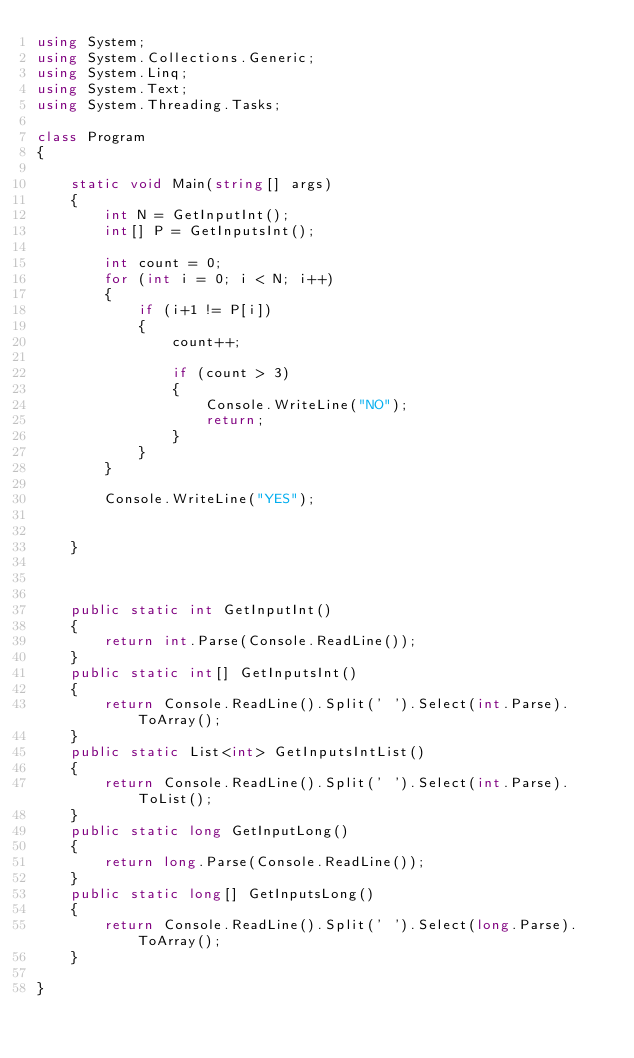Convert code to text. <code><loc_0><loc_0><loc_500><loc_500><_C#_>using System;
using System.Collections.Generic;
using System.Linq;
using System.Text;
using System.Threading.Tasks;
 
class Program
{
 
    static void Main(string[] args)
    {
        int N = GetInputInt();
        int[] P = GetInputsInt();
 
        int count = 0;
        for (int i = 0; i < N; i++)
        {
            if (i+1 != P[i])
            {
                count++;
 
                if (count > 3)
                {
                    Console.WriteLine("NO");
                    return;
                }
            }
        }
 
        Console.WriteLine("YES");
 
 
    }
 
    
 
    public static int GetInputInt()
    {
        return int.Parse(Console.ReadLine());
    }
    public static int[] GetInputsInt()
    {
        return Console.ReadLine().Split(' ').Select(int.Parse).ToArray();
    }
    public static List<int> GetInputsIntList()
    {
        return Console.ReadLine().Split(' ').Select(int.Parse).ToList();
    }
    public static long GetInputLong()
    {
        return long.Parse(Console.ReadLine());
    }
    public static long[] GetInputsLong()
    {
        return Console.ReadLine().Split(' ').Select(long.Parse).ToArray();
    }
 
}</code> 